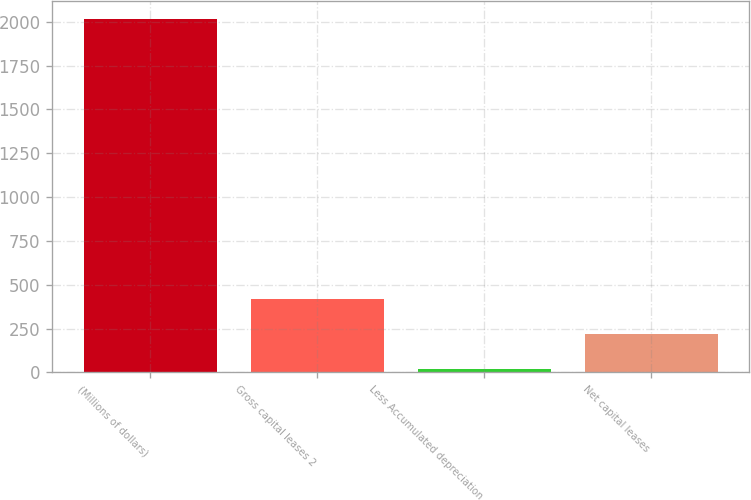Convert chart. <chart><loc_0><loc_0><loc_500><loc_500><bar_chart><fcel>(Millions of dollars)<fcel>Gross capital leases 2<fcel>Less Accumulated depreciation<fcel>Net capital leases<nl><fcel>2017<fcel>418.6<fcel>19<fcel>218.8<nl></chart> 